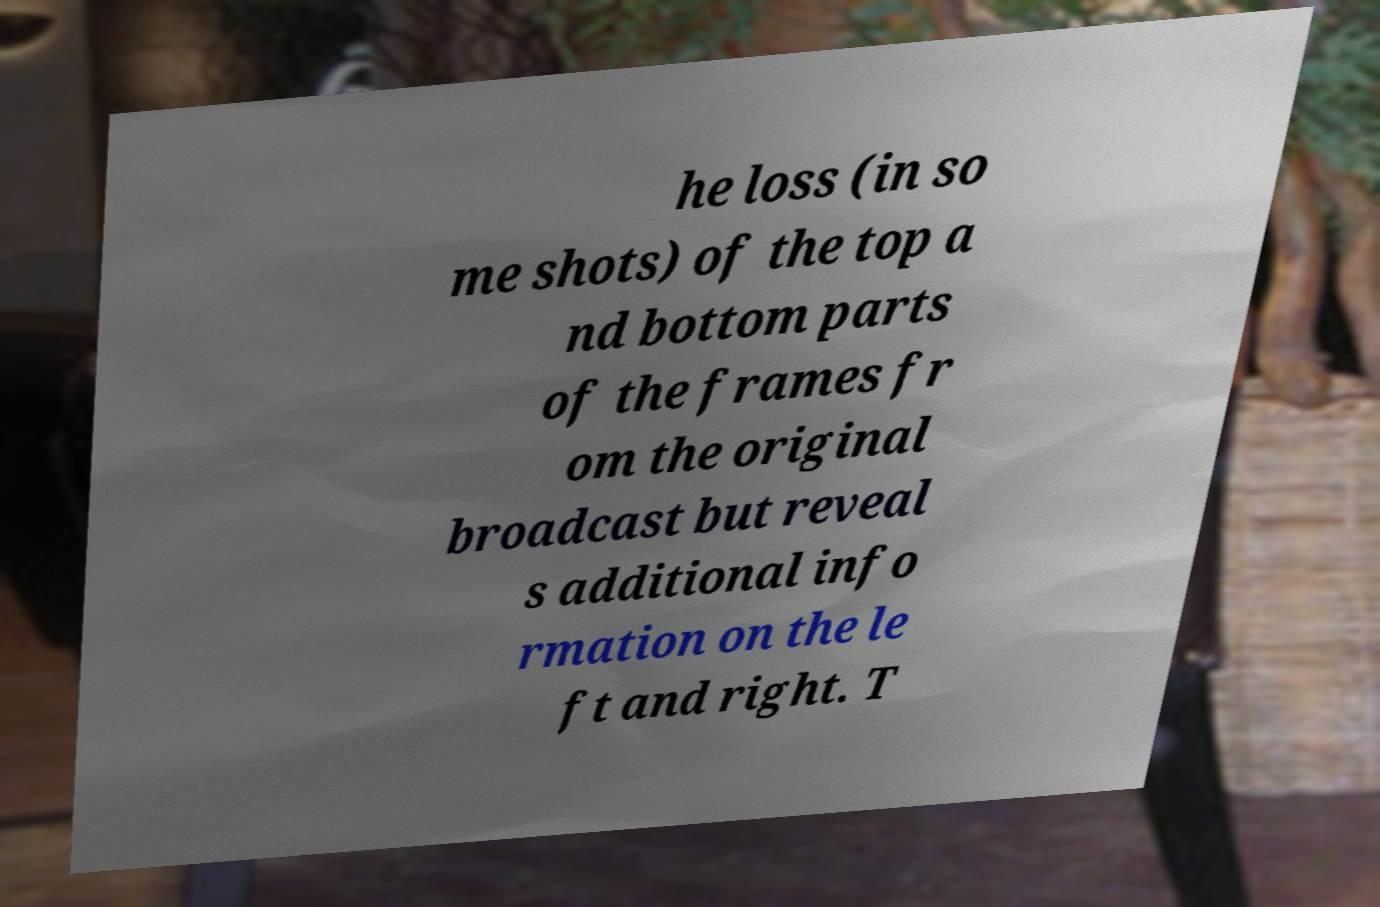For documentation purposes, I need the text within this image transcribed. Could you provide that? he loss (in so me shots) of the top a nd bottom parts of the frames fr om the original broadcast but reveal s additional info rmation on the le ft and right. T 